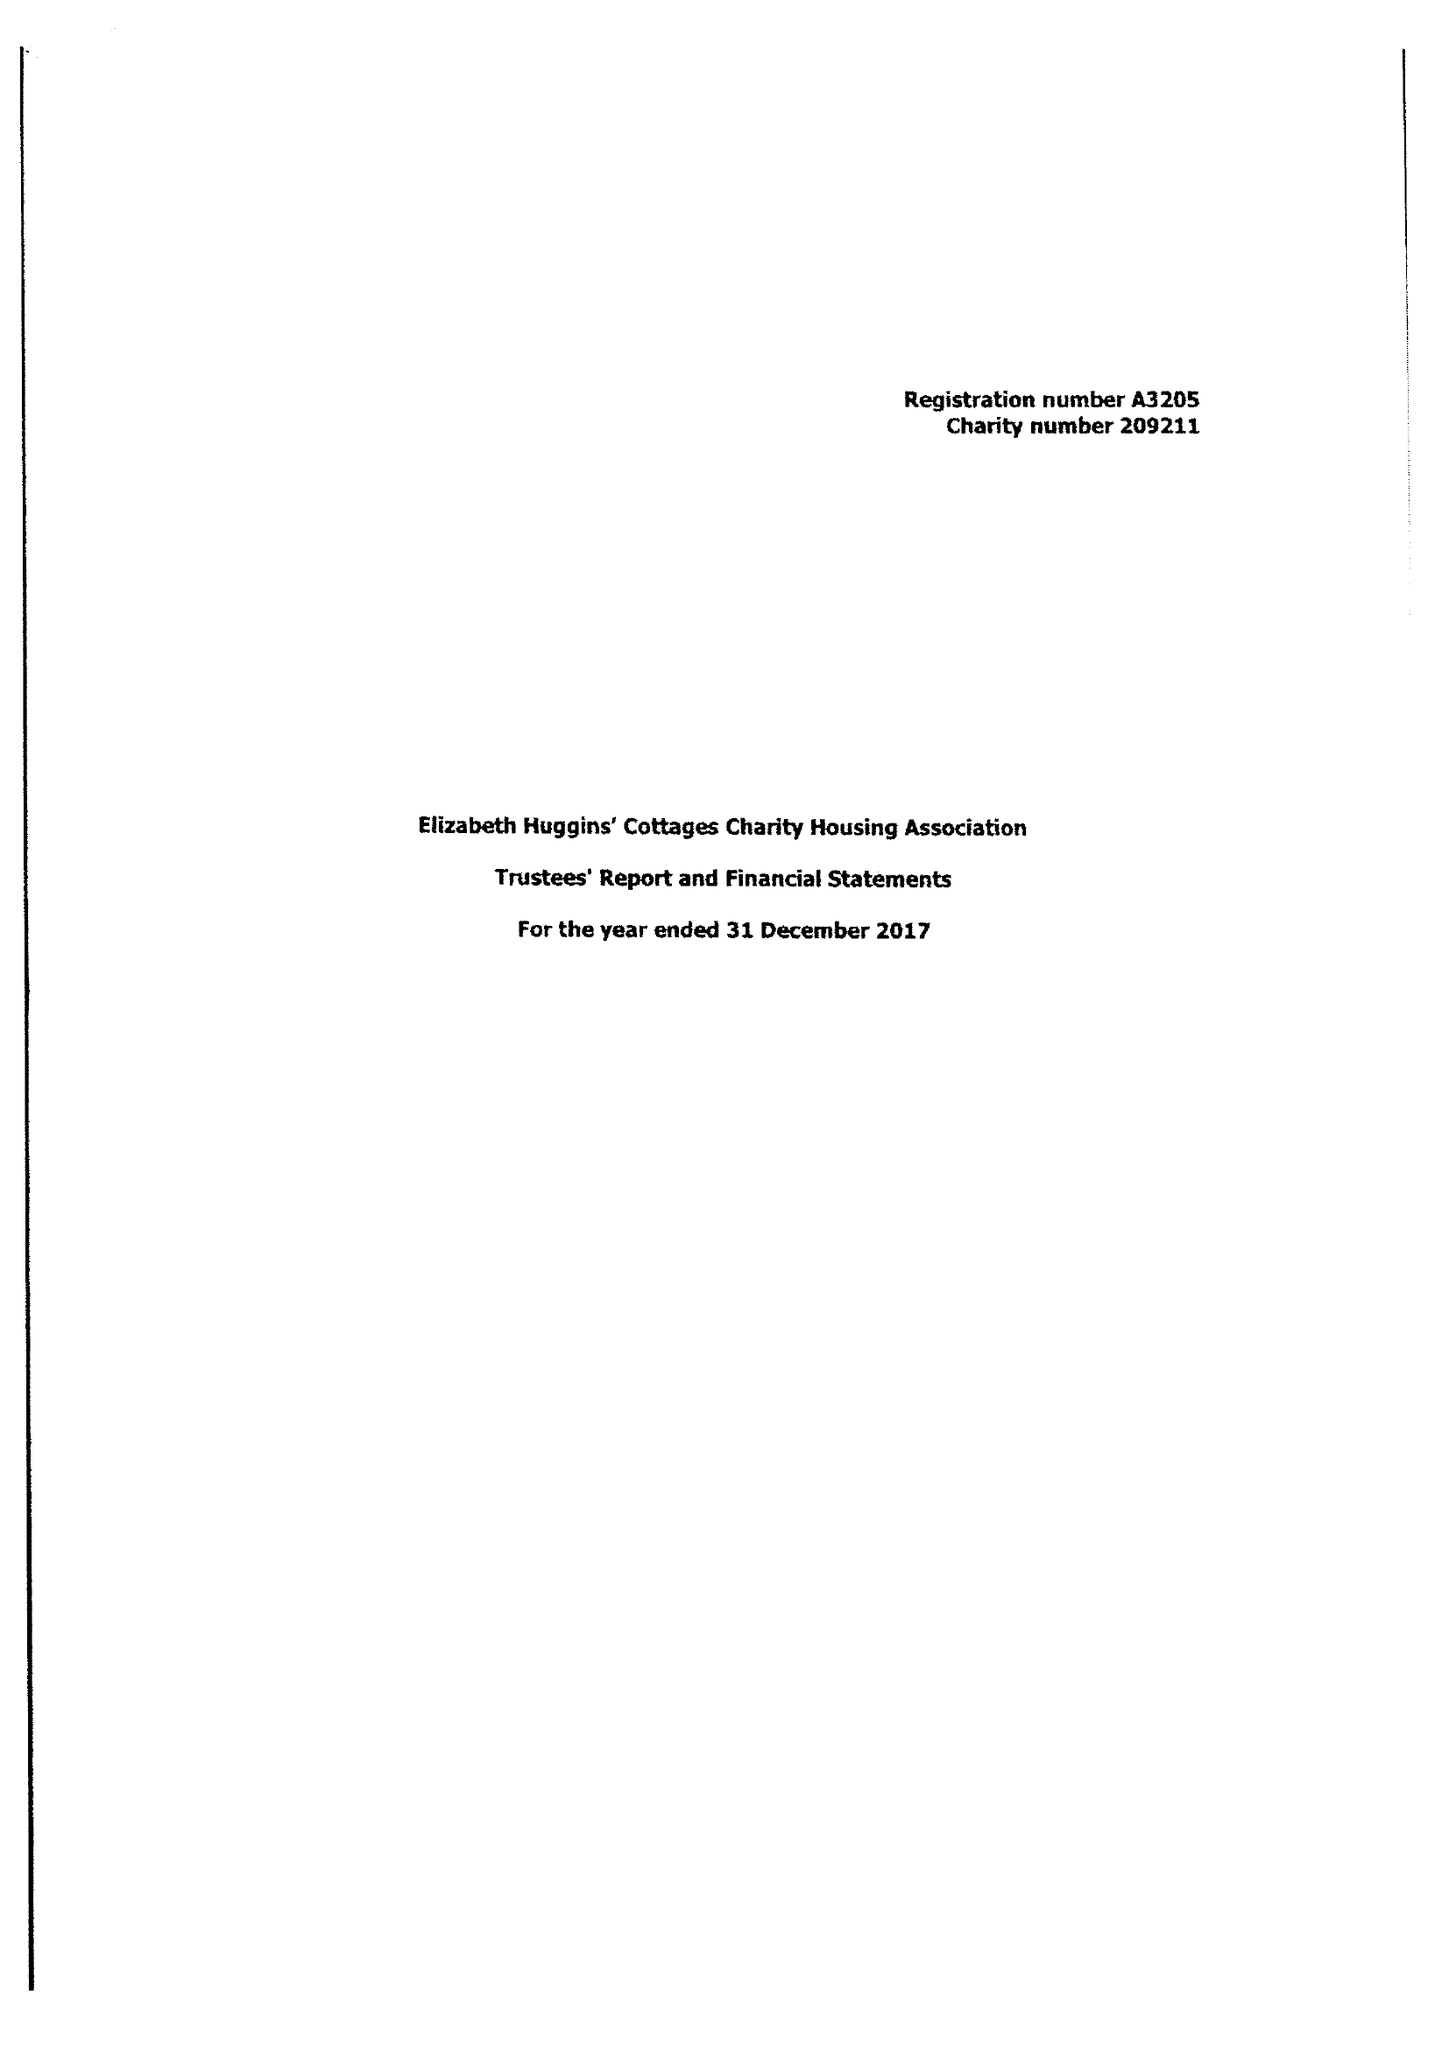What is the value for the charity_name?
Answer the question using a single word or phrase. Elizabeth Huggins' Cottages Charity 